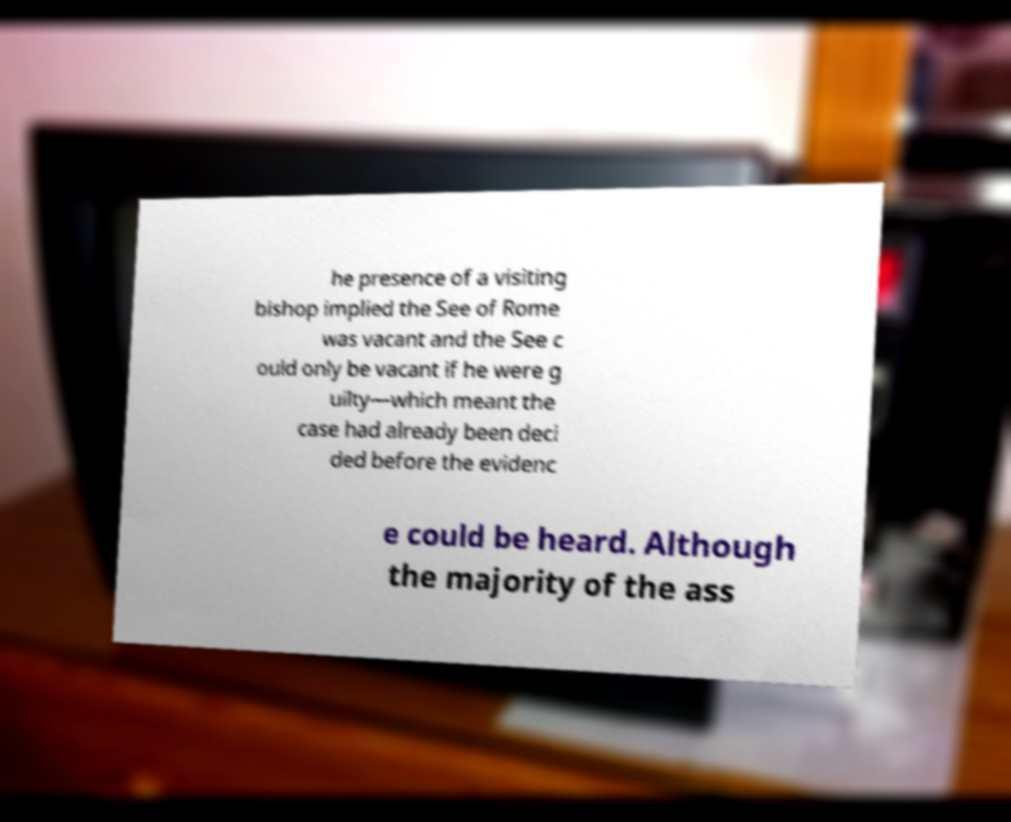Please read and relay the text visible in this image. What does it say? he presence of a visiting bishop implied the See of Rome was vacant and the See c ould only be vacant if he were g uilty—which meant the case had already been deci ded before the evidenc e could be heard. Although the majority of the ass 